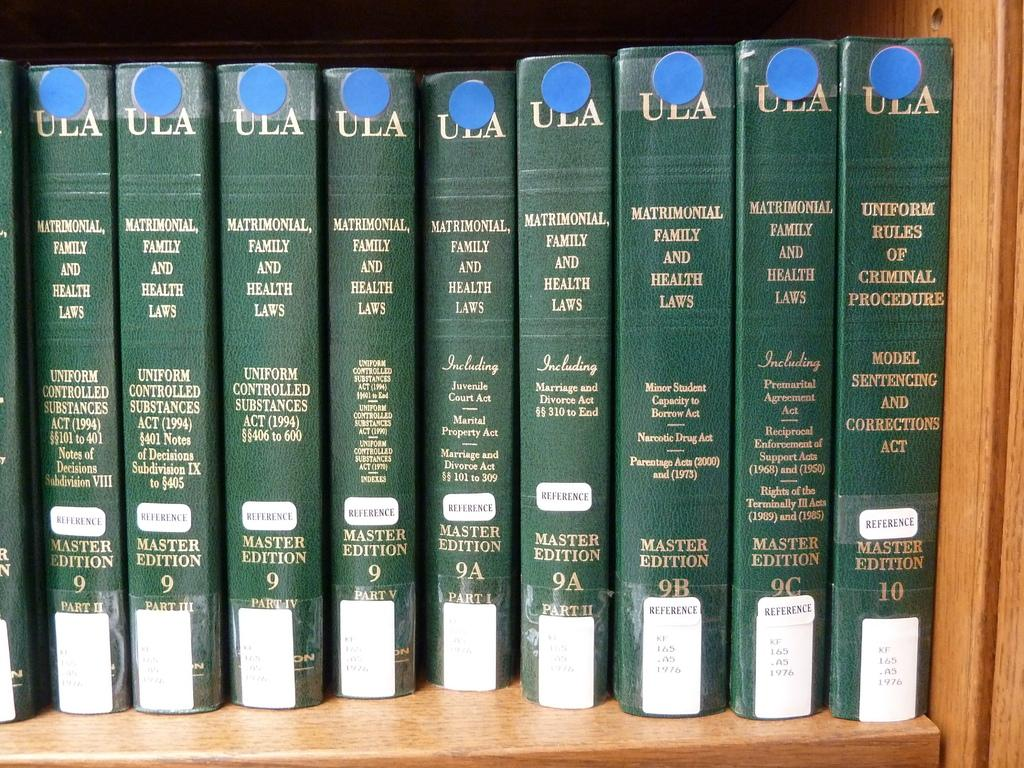<image>
Describe the image concisely. A group of books with the wording mathmatical family and health laws. 